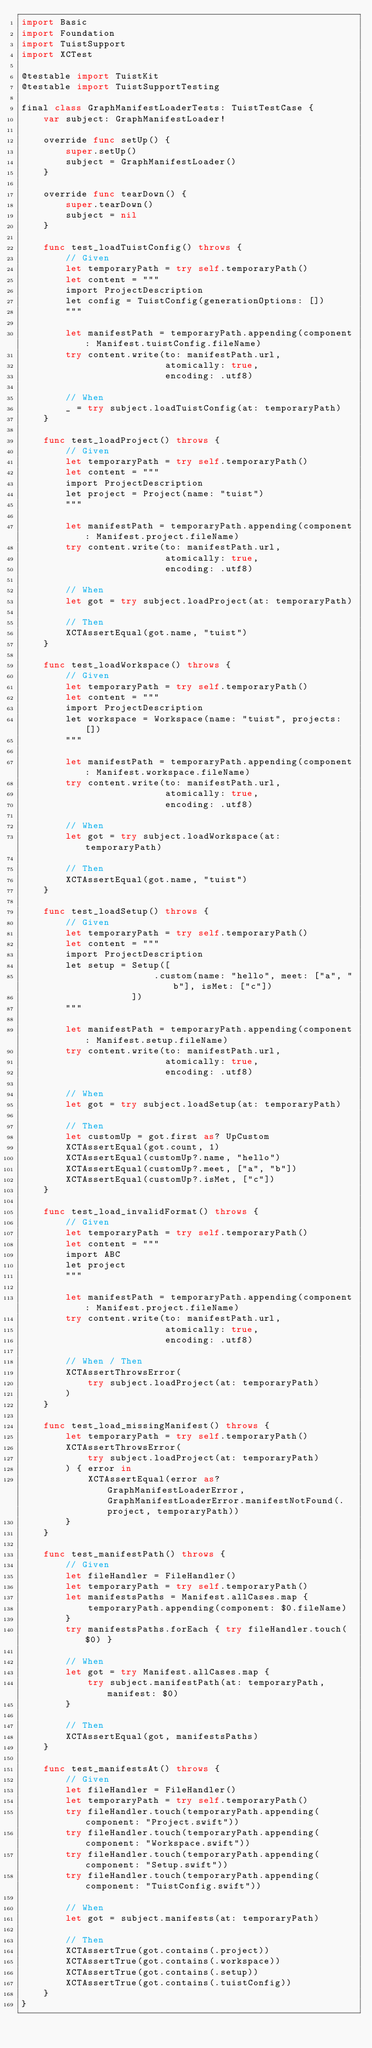Convert code to text. <code><loc_0><loc_0><loc_500><loc_500><_Swift_>import Basic
import Foundation
import TuistSupport
import XCTest

@testable import TuistKit
@testable import TuistSupportTesting

final class GraphManifestLoaderTests: TuistTestCase {
    var subject: GraphManifestLoader!

    override func setUp() {
        super.setUp()
        subject = GraphManifestLoader()
    }

    override func tearDown() {
        super.tearDown()
        subject = nil
    }

    func test_loadTuistConfig() throws {
        // Given
        let temporaryPath = try self.temporaryPath()
        let content = """
        import ProjectDescription
        let config = TuistConfig(generationOptions: [])
        """

        let manifestPath = temporaryPath.appending(component: Manifest.tuistConfig.fileName)
        try content.write(to: manifestPath.url,
                          atomically: true,
                          encoding: .utf8)

        // When
        _ = try subject.loadTuistConfig(at: temporaryPath)
    }

    func test_loadProject() throws {
        // Given
        let temporaryPath = try self.temporaryPath()
        let content = """
        import ProjectDescription
        let project = Project(name: "tuist")
        """

        let manifestPath = temporaryPath.appending(component: Manifest.project.fileName)
        try content.write(to: manifestPath.url,
                          atomically: true,
                          encoding: .utf8)

        // When
        let got = try subject.loadProject(at: temporaryPath)

        // Then
        XCTAssertEqual(got.name, "tuist")
    }

    func test_loadWorkspace() throws {
        // Given
        let temporaryPath = try self.temporaryPath()
        let content = """
        import ProjectDescription
        let workspace = Workspace(name: "tuist", projects: [])
        """

        let manifestPath = temporaryPath.appending(component: Manifest.workspace.fileName)
        try content.write(to: manifestPath.url,
                          atomically: true,
                          encoding: .utf8)

        // When
        let got = try subject.loadWorkspace(at: temporaryPath)

        // Then
        XCTAssertEqual(got.name, "tuist")
    }

    func test_loadSetup() throws {
        // Given
        let temporaryPath = try self.temporaryPath()
        let content = """
        import ProjectDescription
        let setup = Setup([
                        .custom(name: "hello", meet: ["a", "b"], isMet: ["c"])
                    ])
        """

        let manifestPath = temporaryPath.appending(component: Manifest.setup.fileName)
        try content.write(to: manifestPath.url,
                          atomically: true,
                          encoding: .utf8)

        // When
        let got = try subject.loadSetup(at: temporaryPath)

        // Then
        let customUp = got.first as? UpCustom
        XCTAssertEqual(got.count, 1)
        XCTAssertEqual(customUp?.name, "hello")
        XCTAssertEqual(customUp?.meet, ["a", "b"])
        XCTAssertEqual(customUp?.isMet, ["c"])
    }

    func test_load_invalidFormat() throws {
        // Given
        let temporaryPath = try self.temporaryPath()
        let content = """
        import ABC
        let project
        """

        let manifestPath = temporaryPath.appending(component: Manifest.project.fileName)
        try content.write(to: manifestPath.url,
                          atomically: true,
                          encoding: .utf8)

        // When / Then
        XCTAssertThrowsError(
            try subject.loadProject(at: temporaryPath)
        )
    }

    func test_load_missingManifest() throws {
        let temporaryPath = try self.temporaryPath()
        XCTAssertThrowsError(
            try subject.loadProject(at: temporaryPath)
        ) { error in
            XCTAssertEqual(error as? GraphManifestLoaderError, GraphManifestLoaderError.manifestNotFound(.project, temporaryPath))
        }
    }

    func test_manifestPath() throws {
        // Given
        let fileHandler = FileHandler()
        let temporaryPath = try self.temporaryPath()
        let manifestsPaths = Manifest.allCases.map {
            temporaryPath.appending(component: $0.fileName)
        }
        try manifestsPaths.forEach { try fileHandler.touch($0) }

        // When
        let got = try Manifest.allCases.map {
            try subject.manifestPath(at: temporaryPath, manifest: $0)
        }

        // Then
        XCTAssertEqual(got, manifestsPaths)
    }

    func test_manifestsAt() throws {
        // Given
        let fileHandler = FileHandler()
        let temporaryPath = try self.temporaryPath()
        try fileHandler.touch(temporaryPath.appending(component: "Project.swift"))
        try fileHandler.touch(temporaryPath.appending(component: "Workspace.swift"))
        try fileHandler.touch(temporaryPath.appending(component: "Setup.swift"))
        try fileHandler.touch(temporaryPath.appending(component: "TuistConfig.swift"))

        // When
        let got = subject.manifests(at: temporaryPath)

        // Then
        XCTAssertTrue(got.contains(.project))
        XCTAssertTrue(got.contains(.workspace))
        XCTAssertTrue(got.contains(.setup))
        XCTAssertTrue(got.contains(.tuistConfig))
    }
}
</code> 